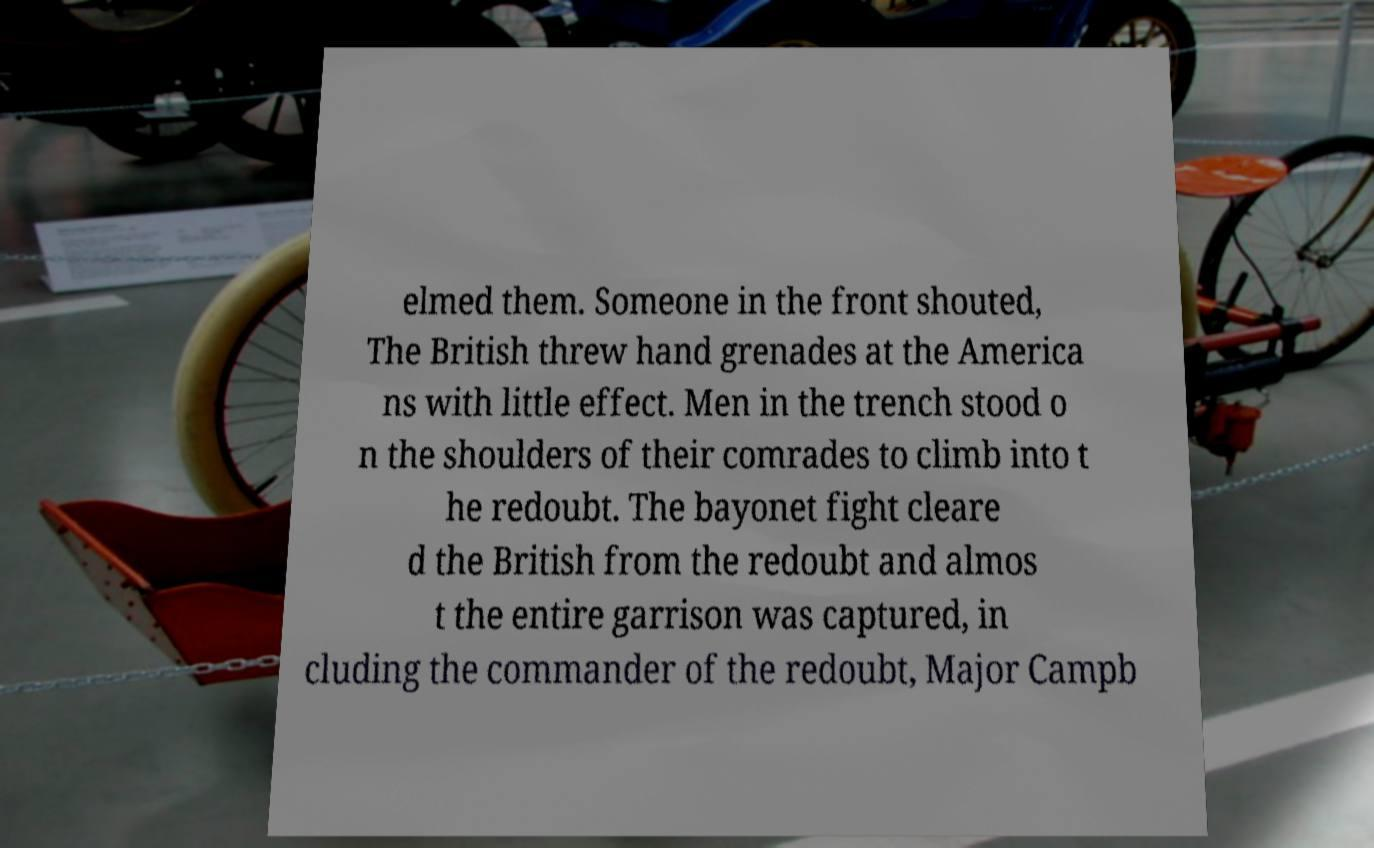Can you accurately transcribe the text from the provided image for me? elmed them. Someone in the front shouted, The British threw hand grenades at the America ns with little effect. Men in the trench stood o n the shoulders of their comrades to climb into t he redoubt. The bayonet fight cleare d the British from the redoubt and almos t the entire garrison was captured, in cluding the commander of the redoubt, Major Campb 